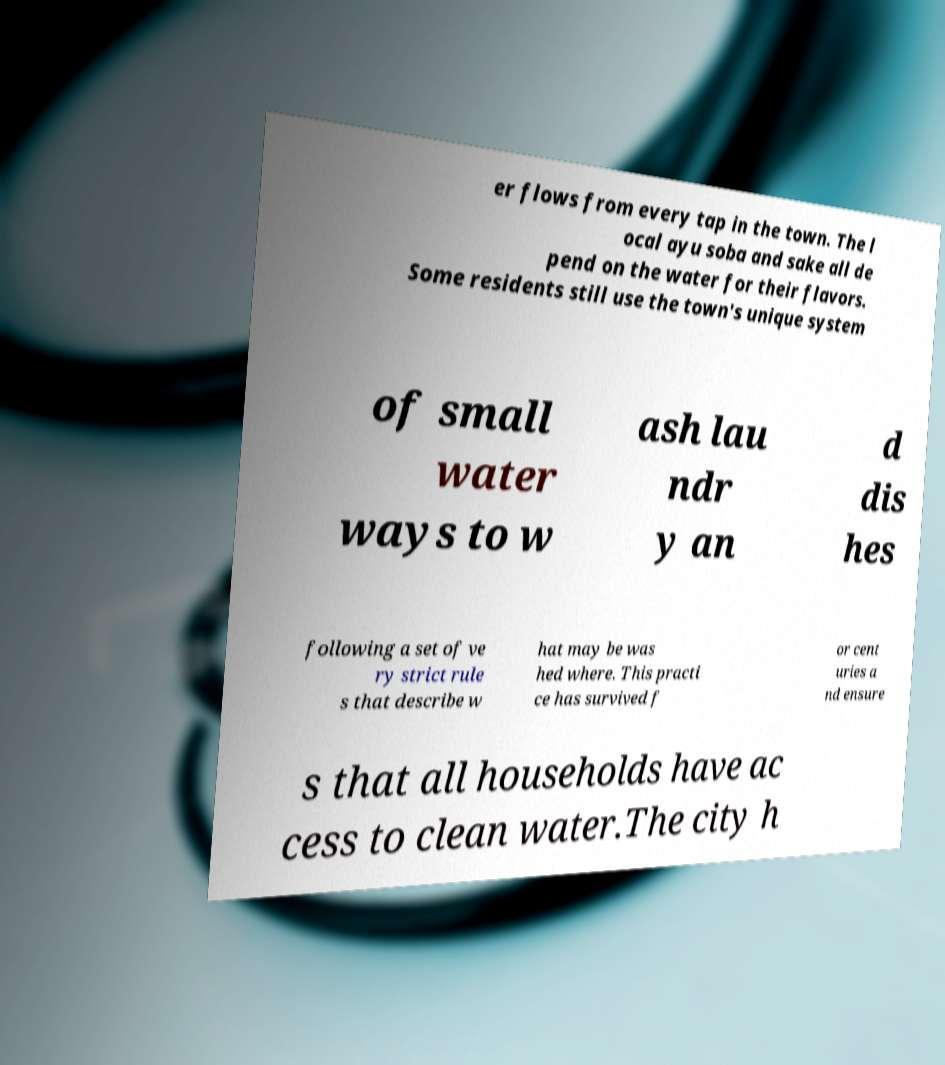Please identify and transcribe the text found in this image. er flows from every tap in the town. The l ocal ayu soba and sake all de pend on the water for their flavors. Some residents still use the town's unique system of small water ways to w ash lau ndr y an d dis hes following a set of ve ry strict rule s that describe w hat may be was hed where. This practi ce has survived f or cent uries a nd ensure s that all households have ac cess to clean water.The city h 